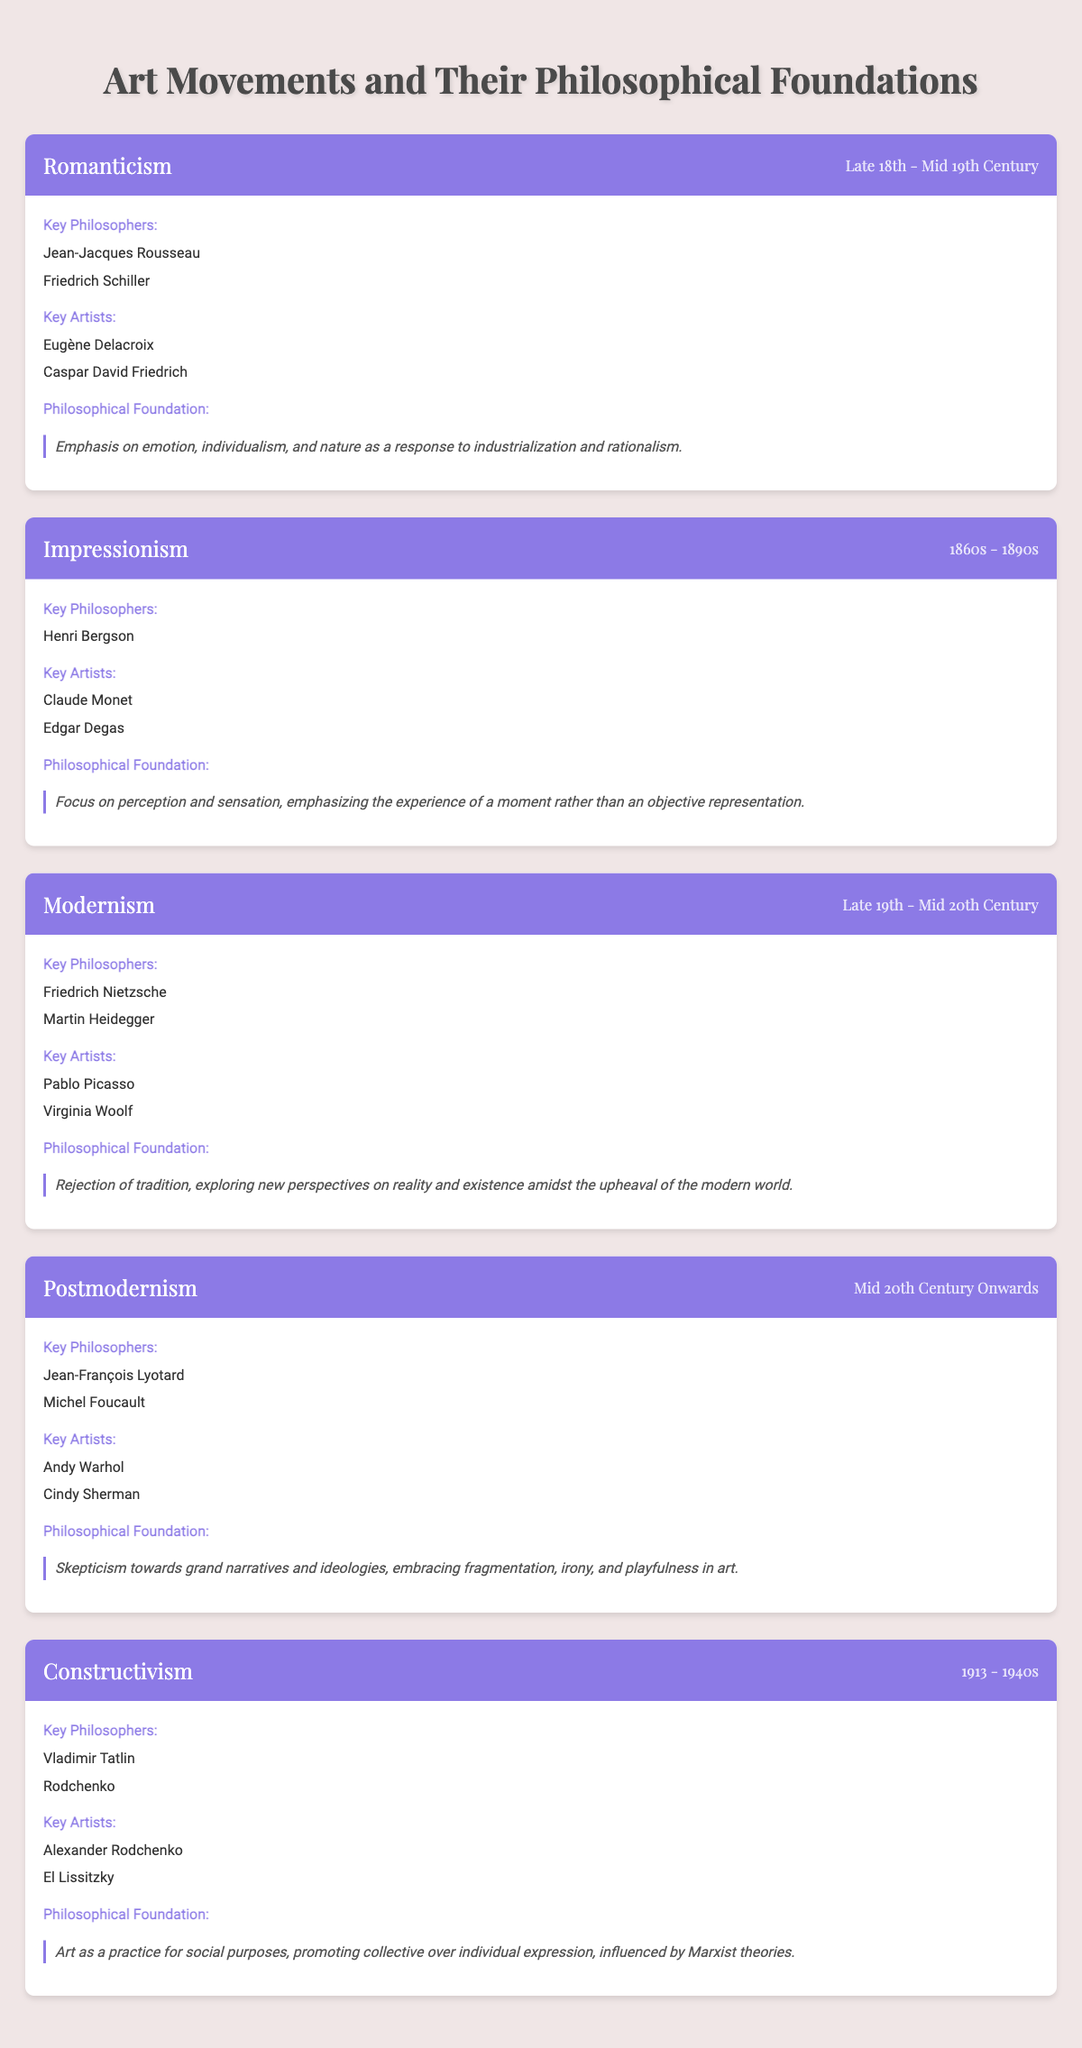What are the key philosophers associated with Impressionism? The table lists Henri Bergson as the only key philosopher associated with Impressionism. This information is found under the section that specifically details key philosophers for that art movement.
Answer: Henri Bergson Which art movement emphasizes emotion and individualism? The table indicates that Romanticism emphasizes emotion and individualism as part of its philosophical foundation. This is directly stated in the description of the philosophical foundation for the Romanticism movement.
Answer: Romanticism How many key artists are mentioned for Modernism? The table shows that there are two key artists associated with Modernism: Pablo Picasso and Virginia Woolf. This total is determined by counting the listed artists under the key artists section of the movement.
Answer: Two Is Michel Foucault considered a key philosopher in Postmodernism? Yes, the table explicitly lists Michel Foucault as a key philosopher associated with Postmodernism, which can be verified in the relevant section of the Postmodernism entry.
Answer: Yes What overarching theme is shared between Modernism and Postmodernism regarding their philosophical foundations? Both movements emphasize a rejection of traditional narratives, with Modernism focusing on exploring new perspectives amidst upheaval, while Postmodernism adopts a skepticism towards grand narratives. This theme can be interpreted by analyzing both philosophical foundations side by side in the table.
Answer: Rejection of traditional narratives 